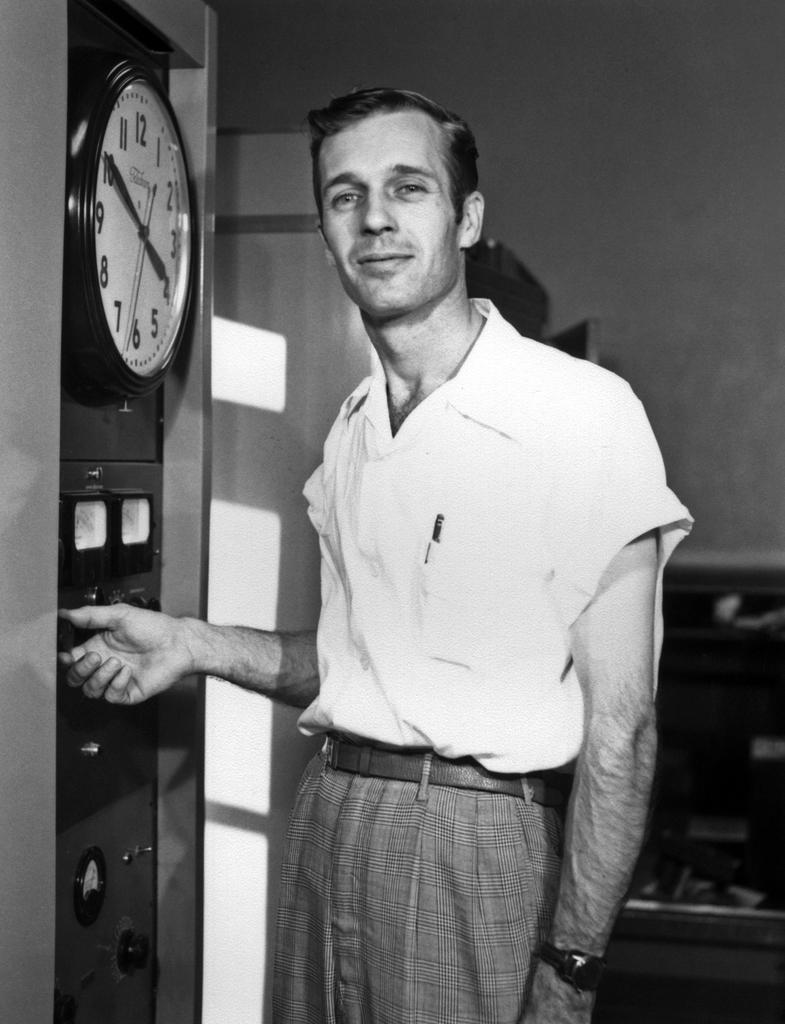<image>
Write a terse but informative summary of the picture. A man standing next to a clock that reads ten minutes to four. 